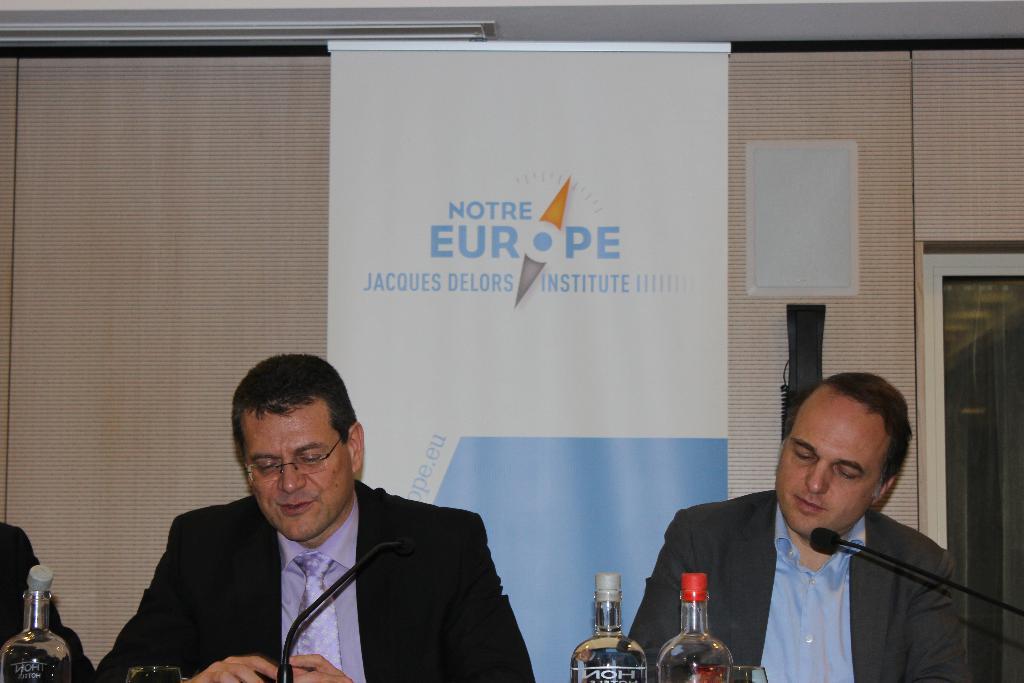What institute is this?
Ensure brevity in your answer.  Jacques delors institute. In what continent is jacques delors institute located?
Provide a short and direct response. Europe. 